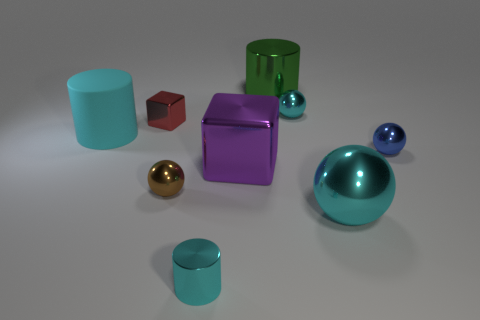There is a small cylinder that is the same color as the rubber thing; what material is it?
Ensure brevity in your answer.  Metal. What is the material of the ball that is the same size as the purple shiny thing?
Your answer should be very brief. Metal. Are there more metal things than large cyan metallic spheres?
Keep it short and to the point. Yes. What is the size of the metallic cylinder that is in front of the tiny object that is left of the brown sphere?
Provide a succinct answer. Small. The red metal object that is the same size as the blue metallic thing is what shape?
Your response must be concise. Cube. There is a small cyan metallic object that is right of the metal cylinder to the left of the big thing behind the small red cube; what is its shape?
Offer a terse response. Sphere. There is a metal object that is to the right of the large cyan sphere; is its color the same as the big metal thing that is left of the big green thing?
Your answer should be compact. No. What number of big red objects are there?
Provide a succinct answer. 0. Are there any cubes in front of the purple block?
Keep it short and to the point. No. Are the small sphere left of the large purple metallic cube and the cylinder to the right of the big cube made of the same material?
Provide a short and direct response. Yes. 